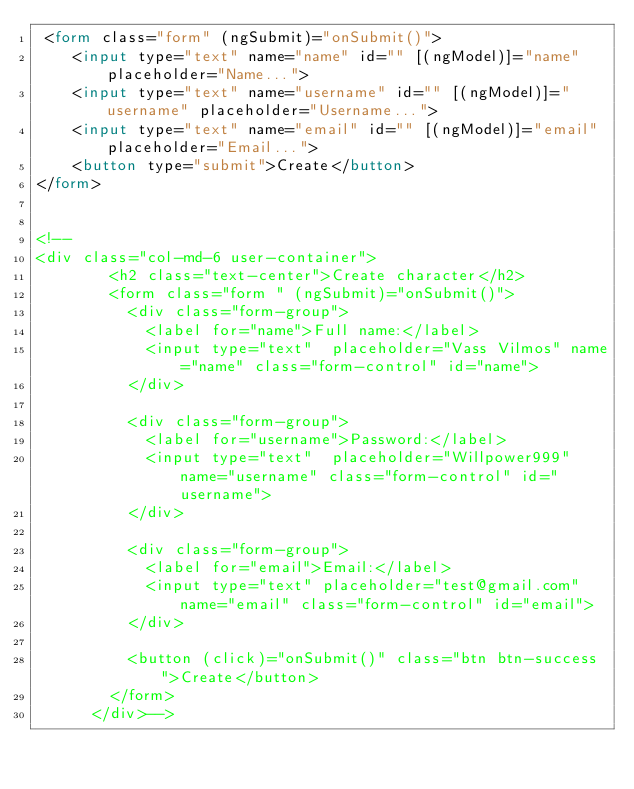Convert code to text. <code><loc_0><loc_0><loc_500><loc_500><_HTML_> <form class="form" (ngSubmit)="onSubmit()">
    <input type="text" name="name" id="" [(ngModel)]="name" placeholder="Name...">
    <input type="text" name="username" id="" [(ngModel)]="username" placeholder="Username...">
    <input type="text" name="email" id="" [(ngModel)]="email" placeholder="Email...">
    <button type="submit">Create</button>
</form>


<!--
<div class="col-md-6 user-container">
        <h2 class="text-center">Create character</h2>
        <form class="form " (ngSubmit)="onSubmit()">
          <div class="form-group">
            <label for="name">Full name:</label>
            <input type="text"  placeholder="Vass Vilmos" name="name" class="form-control" id="name">
          </div>
      
          <div class="form-group">
            <label for="username">Password:</label>
            <input type="text"  placeholder="Willpower999" name="username" class="form-control" id="username">
          </div>
      
          <div class="form-group">
            <label for="email">Email:</label>
            <input type="text" placeholder="test@gmail.com" name="email" class="form-control" id="email">
          </div>
      
          <button (click)="onSubmit()" class="btn btn-success">Create</button>
        </form>
      </div>--></code> 